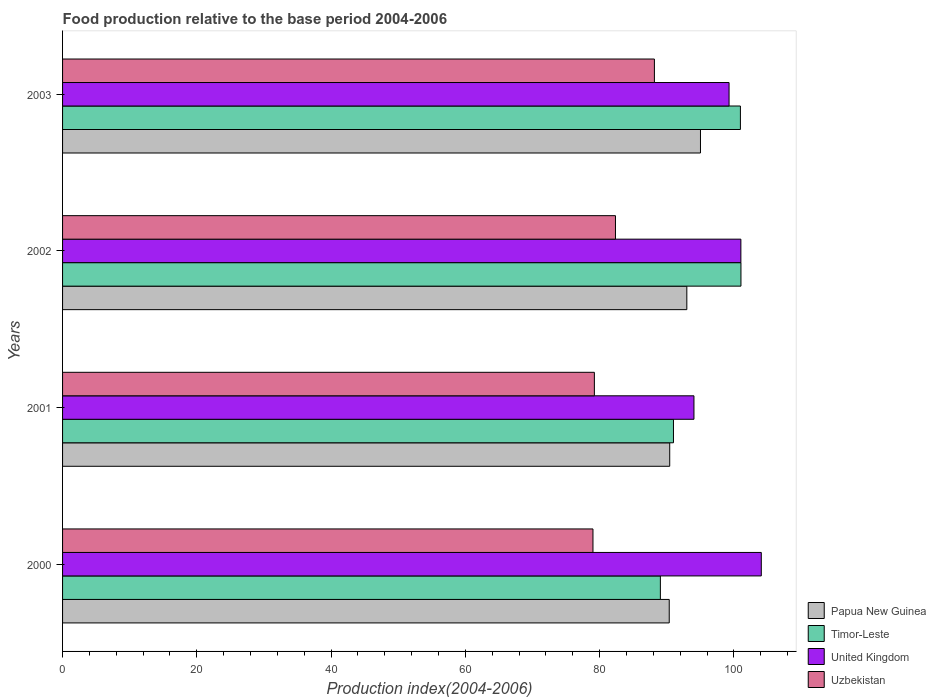How many groups of bars are there?
Offer a terse response. 4. Are the number of bars per tick equal to the number of legend labels?
Make the answer very short. Yes. Are the number of bars on each tick of the Y-axis equal?
Offer a terse response. Yes. How many bars are there on the 2nd tick from the bottom?
Keep it short and to the point. 4. What is the label of the 4th group of bars from the top?
Make the answer very short. 2000. What is the food production index in Timor-Leste in 2000?
Offer a terse response. 89.04. Across all years, what is the maximum food production index in Timor-Leste?
Offer a terse response. 101.04. Across all years, what is the minimum food production index in Timor-Leste?
Your response must be concise. 89.04. In which year was the food production index in Timor-Leste maximum?
Keep it short and to the point. 2002. What is the total food production index in Papua New Guinea in the graph?
Give a very brief answer. 368.78. What is the difference between the food production index in Uzbekistan in 2001 and that in 2003?
Offer a very short reply. -8.94. What is the difference between the food production index in United Kingdom in 2000 and the food production index in Papua New Guinea in 2001?
Your answer should be very brief. 13.64. What is the average food production index in Uzbekistan per year?
Offer a terse response. 82.18. In the year 2001, what is the difference between the food production index in Papua New Guinea and food production index in United Kingdom?
Your answer should be compact. -3.61. What is the ratio of the food production index in Timor-Leste in 2001 to that in 2003?
Give a very brief answer. 0.9. Is the food production index in Uzbekistan in 2002 less than that in 2003?
Give a very brief answer. Yes. What is the difference between the highest and the second highest food production index in United Kingdom?
Offer a very short reply. 3.04. What is the difference between the highest and the lowest food production index in Uzbekistan?
Keep it short and to the point. 9.15. Is the sum of the food production index in United Kingdom in 2000 and 2002 greater than the maximum food production index in Timor-Leste across all years?
Provide a succinct answer. Yes. What does the 1st bar from the top in 2001 represents?
Your answer should be very brief. Uzbekistan. Is it the case that in every year, the sum of the food production index in Timor-Leste and food production index in United Kingdom is greater than the food production index in Uzbekistan?
Your answer should be compact. Yes. How many bars are there?
Your response must be concise. 16. How many years are there in the graph?
Your response must be concise. 4. Does the graph contain any zero values?
Your response must be concise. No. Does the graph contain grids?
Your answer should be compact. No. How are the legend labels stacked?
Keep it short and to the point. Vertical. What is the title of the graph?
Your answer should be compact. Food production relative to the base period 2004-2006. Does "Oman" appear as one of the legend labels in the graph?
Make the answer very short. No. What is the label or title of the X-axis?
Your answer should be compact. Production index(2004-2006). What is the Production index(2004-2006) in Papua New Guinea in 2000?
Offer a very short reply. 90.36. What is the Production index(2004-2006) of Timor-Leste in 2000?
Provide a succinct answer. 89.04. What is the Production index(2004-2006) of United Kingdom in 2000?
Offer a very short reply. 104.07. What is the Production index(2004-2006) in Uzbekistan in 2000?
Your answer should be compact. 79. What is the Production index(2004-2006) of Papua New Guinea in 2001?
Ensure brevity in your answer.  90.43. What is the Production index(2004-2006) in Timor-Leste in 2001?
Your answer should be very brief. 90.99. What is the Production index(2004-2006) in United Kingdom in 2001?
Offer a terse response. 94.04. What is the Production index(2004-2006) of Uzbekistan in 2001?
Ensure brevity in your answer.  79.21. What is the Production index(2004-2006) in Papua New Guinea in 2002?
Make the answer very short. 92.98. What is the Production index(2004-2006) of Timor-Leste in 2002?
Your answer should be very brief. 101.04. What is the Production index(2004-2006) of United Kingdom in 2002?
Make the answer very short. 101.03. What is the Production index(2004-2006) in Uzbekistan in 2002?
Ensure brevity in your answer.  82.35. What is the Production index(2004-2006) of Papua New Guinea in 2003?
Offer a very short reply. 95.01. What is the Production index(2004-2006) of Timor-Leste in 2003?
Your answer should be very brief. 100.96. What is the Production index(2004-2006) of United Kingdom in 2003?
Offer a very short reply. 99.27. What is the Production index(2004-2006) in Uzbekistan in 2003?
Ensure brevity in your answer.  88.15. Across all years, what is the maximum Production index(2004-2006) in Papua New Guinea?
Give a very brief answer. 95.01. Across all years, what is the maximum Production index(2004-2006) of Timor-Leste?
Your answer should be very brief. 101.04. Across all years, what is the maximum Production index(2004-2006) in United Kingdom?
Provide a short and direct response. 104.07. Across all years, what is the maximum Production index(2004-2006) in Uzbekistan?
Make the answer very short. 88.15. Across all years, what is the minimum Production index(2004-2006) in Papua New Guinea?
Offer a terse response. 90.36. Across all years, what is the minimum Production index(2004-2006) in Timor-Leste?
Provide a succinct answer. 89.04. Across all years, what is the minimum Production index(2004-2006) in United Kingdom?
Provide a short and direct response. 94.04. Across all years, what is the minimum Production index(2004-2006) in Uzbekistan?
Offer a very short reply. 79. What is the total Production index(2004-2006) of Papua New Guinea in the graph?
Offer a terse response. 368.78. What is the total Production index(2004-2006) in Timor-Leste in the graph?
Make the answer very short. 382.03. What is the total Production index(2004-2006) in United Kingdom in the graph?
Provide a short and direct response. 398.41. What is the total Production index(2004-2006) of Uzbekistan in the graph?
Your answer should be very brief. 328.71. What is the difference between the Production index(2004-2006) in Papua New Guinea in 2000 and that in 2001?
Your answer should be compact. -0.07. What is the difference between the Production index(2004-2006) of Timor-Leste in 2000 and that in 2001?
Your answer should be compact. -1.95. What is the difference between the Production index(2004-2006) of United Kingdom in 2000 and that in 2001?
Give a very brief answer. 10.03. What is the difference between the Production index(2004-2006) in Uzbekistan in 2000 and that in 2001?
Your answer should be compact. -0.21. What is the difference between the Production index(2004-2006) in Papua New Guinea in 2000 and that in 2002?
Ensure brevity in your answer.  -2.62. What is the difference between the Production index(2004-2006) of United Kingdom in 2000 and that in 2002?
Offer a very short reply. 3.04. What is the difference between the Production index(2004-2006) of Uzbekistan in 2000 and that in 2002?
Your answer should be compact. -3.35. What is the difference between the Production index(2004-2006) of Papua New Guinea in 2000 and that in 2003?
Offer a terse response. -4.65. What is the difference between the Production index(2004-2006) in Timor-Leste in 2000 and that in 2003?
Ensure brevity in your answer.  -11.92. What is the difference between the Production index(2004-2006) of Uzbekistan in 2000 and that in 2003?
Your answer should be compact. -9.15. What is the difference between the Production index(2004-2006) in Papua New Guinea in 2001 and that in 2002?
Ensure brevity in your answer.  -2.55. What is the difference between the Production index(2004-2006) in Timor-Leste in 2001 and that in 2002?
Ensure brevity in your answer.  -10.05. What is the difference between the Production index(2004-2006) of United Kingdom in 2001 and that in 2002?
Offer a terse response. -6.99. What is the difference between the Production index(2004-2006) of Uzbekistan in 2001 and that in 2002?
Offer a terse response. -3.14. What is the difference between the Production index(2004-2006) in Papua New Guinea in 2001 and that in 2003?
Your answer should be compact. -4.58. What is the difference between the Production index(2004-2006) in Timor-Leste in 2001 and that in 2003?
Your response must be concise. -9.97. What is the difference between the Production index(2004-2006) in United Kingdom in 2001 and that in 2003?
Offer a very short reply. -5.23. What is the difference between the Production index(2004-2006) in Uzbekistan in 2001 and that in 2003?
Provide a succinct answer. -8.94. What is the difference between the Production index(2004-2006) of Papua New Guinea in 2002 and that in 2003?
Ensure brevity in your answer.  -2.03. What is the difference between the Production index(2004-2006) of Timor-Leste in 2002 and that in 2003?
Keep it short and to the point. 0.08. What is the difference between the Production index(2004-2006) of United Kingdom in 2002 and that in 2003?
Provide a succinct answer. 1.76. What is the difference between the Production index(2004-2006) of Uzbekistan in 2002 and that in 2003?
Offer a terse response. -5.8. What is the difference between the Production index(2004-2006) in Papua New Guinea in 2000 and the Production index(2004-2006) in Timor-Leste in 2001?
Your response must be concise. -0.63. What is the difference between the Production index(2004-2006) of Papua New Guinea in 2000 and the Production index(2004-2006) of United Kingdom in 2001?
Offer a very short reply. -3.68. What is the difference between the Production index(2004-2006) in Papua New Guinea in 2000 and the Production index(2004-2006) in Uzbekistan in 2001?
Offer a terse response. 11.15. What is the difference between the Production index(2004-2006) in Timor-Leste in 2000 and the Production index(2004-2006) in Uzbekistan in 2001?
Your response must be concise. 9.83. What is the difference between the Production index(2004-2006) of United Kingdom in 2000 and the Production index(2004-2006) of Uzbekistan in 2001?
Offer a very short reply. 24.86. What is the difference between the Production index(2004-2006) of Papua New Guinea in 2000 and the Production index(2004-2006) of Timor-Leste in 2002?
Offer a very short reply. -10.68. What is the difference between the Production index(2004-2006) in Papua New Guinea in 2000 and the Production index(2004-2006) in United Kingdom in 2002?
Offer a very short reply. -10.67. What is the difference between the Production index(2004-2006) in Papua New Guinea in 2000 and the Production index(2004-2006) in Uzbekistan in 2002?
Your answer should be compact. 8.01. What is the difference between the Production index(2004-2006) of Timor-Leste in 2000 and the Production index(2004-2006) of United Kingdom in 2002?
Ensure brevity in your answer.  -11.99. What is the difference between the Production index(2004-2006) of Timor-Leste in 2000 and the Production index(2004-2006) of Uzbekistan in 2002?
Keep it short and to the point. 6.69. What is the difference between the Production index(2004-2006) of United Kingdom in 2000 and the Production index(2004-2006) of Uzbekistan in 2002?
Your answer should be very brief. 21.72. What is the difference between the Production index(2004-2006) of Papua New Guinea in 2000 and the Production index(2004-2006) of Timor-Leste in 2003?
Provide a short and direct response. -10.6. What is the difference between the Production index(2004-2006) in Papua New Guinea in 2000 and the Production index(2004-2006) in United Kingdom in 2003?
Your response must be concise. -8.91. What is the difference between the Production index(2004-2006) of Papua New Guinea in 2000 and the Production index(2004-2006) of Uzbekistan in 2003?
Ensure brevity in your answer.  2.21. What is the difference between the Production index(2004-2006) in Timor-Leste in 2000 and the Production index(2004-2006) in United Kingdom in 2003?
Make the answer very short. -10.23. What is the difference between the Production index(2004-2006) in Timor-Leste in 2000 and the Production index(2004-2006) in Uzbekistan in 2003?
Your answer should be compact. 0.89. What is the difference between the Production index(2004-2006) in United Kingdom in 2000 and the Production index(2004-2006) in Uzbekistan in 2003?
Keep it short and to the point. 15.92. What is the difference between the Production index(2004-2006) of Papua New Guinea in 2001 and the Production index(2004-2006) of Timor-Leste in 2002?
Make the answer very short. -10.61. What is the difference between the Production index(2004-2006) of Papua New Guinea in 2001 and the Production index(2004-2006) of Uzbekistan in 2002?
Keep it short and to the point. 8.08. What is the difference between the Production index(2004-2006) in Timor-Leste in 2001 and the Production index(2004-2006) in United Kingdom in 2002?
Offer a terse response. -10.04. What is the difference between the Production index(2004-2006) in Timor-Leste in 2001 and the Production index(2004-2006) in Uzbekistan in 2002?
Give a very brief answer. 8.64. What is the difference between the Production index(2004-2006) of United Kingdom in 2001 and the Production index(2004-2006) of Uzbekistan in 2002?
Make the answer very short. 11.69. What is the difference between the Production index(2004-2006) in Papua New Guinea in 2001 and the Production index(2004-2006) in Timor-Leste in 2003?
Provide a succinct answer. -10.53. What is the difference between the Production index(2004-2006) of Papua New Guinea in 2001 and the Production index(2004-2006) of United Kingdom in 2003?
Offer a terse response. -8.84. What is the difference between the Production index(2004-2006) in Papua New Guinea in 2001 and the Production index(2004-2006) in Uzbekistan in 2003?
Your answer should be very brief. 2.28. What is the difference between the Production index(2004-2006) of Timor-Leste in 2001 and the Production index(2004-2006) of United Kingdom in 2003?
Ensure brevity in your answer.  -8.28. What is the difference between the Production index(2004-2006) of Timor-Leste in 2001 and the Production index(2004-2006) of Uzbekistan in 2003?
Your answer should be compact. 2.84. What is the difference between the Production index(2004-2006) of United Kingdom in 2001 and the Production index(2004-2006) of Uzbekistan in 2003?
Provide a succinct answer. 5.89. What is the difference between the Production index(2004-2006) in Papua New Guinea in 2002 and the Production index(2004-2006) in Timor-Leste in 2003?
Your response must be concise. -7.98. What is the difference between the Production index(2004-2006) of Papua New Guinea in 2002 and the Production index(2004-2006) of United Kingdom in 2003?
Your answer should be very brief. -6.29. What is the difference between the Production index(2004-2006) in Papua New Guinea in 2002 and the Production index(2004-2006) in Uzbekistan in 2003?
Offer a very short reply. 4.83. What is the difference between the Production index(2004-2006) in Timor-Leste in 2002 and the Production index(2004-2006) in United Kingdom in 2003?
Your answer should be compact. 1.77. What is the difference between the Production index(2004-2006) in Timor-Leste in 2002 and the Production index(2004-2006) in Uzbekistan in 2003?
Provide a short and direct response. 12.89. What is the difference between the Production index(2004-2006) in United Kingdom in 2002 and the Production index(2004-2006) in Uzbekistan in 2003?
Your answer should be compact. 12.88. What is the average Production index(2004-2006) of Papua New Guinea per year?
Your answer should be very brief. 92.19. What is the average Production index(2004-2006) of Timor-Leste per year?
Offer a terse response. 95.51. What is the average Production index(2004-2006) of United Kingdom per year?
Provide a succinct answer. 99.6. What is the average Production index(2004-2006) of Uzbekistan per year?
Give a very brief answer. 82.18. In the year 2000, what is the difference between the Production index(2004-2006) in Papua New Guinea and Production index(2004-2006) in Timor-Leste?
Offer a terse response. 1.32. In the year 2000, what is the difference between the Production index(2004-2006) of Papua New Guinea and Production index(2004-2006) of United Kingdom?
Ensure brevity in your answer.  -13.71. In the year 2000, what is the difference between the Production index(2004-2006) in Papua New Guinea and Production index(2004-2006) in Uzbekistan?
Offer a terse response. 11.36. In the year 2000, what is the difference between the Production index(2004-2006) in Timor-Leste and Production index(2004-2006) in United Kingdom?
Ensure brevity in your answer.  -15.03. In the year 2000, what is the difference between the Production index(2004-2006) of Timor-Leste and Production index(2004-2006) of Uzbekistan?
Your answer should be very brief. 10.04. In the year 2000, what is the difference between the Production index(2004-2006) of United Kingdom and Production index(2004-2006) of Uzbekistan?
Offer a very short reply. 25.07. In the year 2001, what is the difference between the Production index(2004-2006) of Papua New Guinea and Production index(2004-2006) of Timor-Leste?
Your response must be concise. -0.56. In the year 2001, what is the difference between the Production index(2004-2006) of Papua New Guinea and Production index(2004-2006) of United Kingdom?
Keep it short and to the point. -3.61. In the year 2001, what is the difference between the Production index(2004-2006) in Papua New Guinea and Production index(2004-2006) in Uzbekistan?
Offer a very short reply. 11.22. In the year 2001, what is the difference between the Production index(2004-2006) in Timor-Leste and Production index(2004-2006) in United Kingdom?
Give a very brief answer. -3.05. In the year 2001, what is the difference between the Production index(2004-2006) in Timor-Leste and Production index(2004-2006) in Uzbekistan?
Make the answer very short. 11.78. In the year 2001, what is the difference between the Production index(2004-2006) of United Kingdom and Production index(2004-2006) of Uzbekistan?
Ensure brevity in your answer.  14.83. In the year 2002, what is the difference between the Production index(2004-2006) of Papua New Guinea and Production index(2004-2006) of Timor-Leste?
Your answer should be very brief. -8.06. In the year 2002, what is the difference between the Production index(2004-2006) in Papua New Guinea and Production index(2004-2006) in United Kingdom?
Provide a short and direct response. -8.05. In the year 2002, what is the difference between the Production index(2004-2006) of Papua New Guinea and Production index(2004-2006) of Uzbekistan?
Offer a terse response. 10.63. In the year 2002, what is the difference between the Production index(2004-2006) of Timor-Leste and Production index(2004-2006) of Uzbekistan?
Your response must be concise. 18.69. In the year 2002, what is the difference between the Production index(2004-2006) in United Kingdom and Production index(2004-2006) in Uzbekistan?
Your answer should be very brief. 18.68. In the year 2003, what is the difference between the Production index(2004-2006) of Papua New Guinea and Production index(2004-2006) of Timor-Leste?
Offer a very short reply. -5.95. In the year 2003, what is the difference between the Production index(2004-2006) in Papua New Guinea and Production index(2004-2006) in United Kingdom?
Provide a succinct answer. -4.26. In the year 2003, what is the difference between the Production index(2004-2006) in Papua New Guinea and Production index(2004-2006) in Uzbekistan?
Ensure brevity in your answer.  6.86. In the year 2003, what is the difference between the Production index(2004-2006) of Timor-Leste and Production index(2004-2006) of United Kingdom?
Provide a succinct answer. 1.69. In the year 2003, what is the difference between the Production index(2004-2006) of Timor-Leste and Production index(2004-2006) of Uzbekistan?
Provide a short and direct response. 12.81. In the year 2003, what is the difference between the Production index(2004-2006) in United Kingdom and Production index(2004-2006) in Uzbekistan?
Your answer should be compact. 11.12. What is the ratio of the Production index(2004-2006) of Papua New Guinea in 2000 to that in 2001?
Provide a short and direct response. 1. What is the ratio of the Production index(2004-2006) of Timor-Leste in 2000 to that in 2001?
Your response must be concise. 0.98. What is the ratio of the Production index(2004-2006) of United Kingdom in 2000 to that in 2001?
Make the answer very short. 1.11. What is the ratio of the Production index(2004-2006) in Uzbekistan in 2000 to that in 2001?
Your answer should be very brief. 1. What is the ratio of the Production index(2004-2006) of Papua New Guinea in 2000 to that in 2002?
Your answer should be compact. 0.97. What is the ratio of the Production index(2004-2006) of Timor-Leste in 2000 to that in 2002?
Provide a short and direct response. 0.88. What is the ratio of the Production index(2004-2006) in United Kingdom in 2000 to that in 2002?
Offer a very short reply. 1.03. What is the ratio of the Production index(2004-2006) in Uzbekistan in 2000 to that in 2002?
Give a very brief answer. 0.96. What is the ratio of the Production index(2004-2006) of Papua New Guinea in 2000 to that in 2003?
Your response must be concise. 0.95. What is the ratio of the Production index(2004-2006) in Timor-Leste in 2000 to that in 2003?
Offer a very short reply. 0.88. What is the ratio of the Production index(2004-2006) in United Kingdom in 2000 to that in 2003?
Your response must be concise. 1.05. What is the ratio of the Production index(2004-2006) of Uzbekistan in 2000 to that in 2003?
Keep it short and to the point. 0.9. What is the ratio of the Production index(2004-2006) of Papua New Guinea in 2001 to that in 2002?
Your answer should be compact. 0.97. What is the ratio of the Production index(2004-2006) in Timor-Leste in 2001 to that in 2002?
Your answer should be very brief. 0.9. What is the ratio of the Production index(2004-2006) in United Kingdom in 2001 to that in 2002?
Make the answer very short. 0.93. What is the ratio of the Production index(2004-2006) of Uzbekistan in 2001 to that in 2002?
Offer a very short reply. 0.96. What is the ratio of the Production index(2004-2006) in Papua New Guinea in 2001 to that in 2003?
Offer a terse response. 0.95. What is the ratio of the Production index(2004-2006) in Timor-Leste in 2001 to that in 2003?
Make the answer very short. 0.9. What is the ratio of the Production index(2004-2006) in United Kingdom in 2001 to that in 2003?
Keep it short and to the point. 0.95. What is the ratio of the Production index(2004-2006) of Uzbekistan in 2001 to that in 2003?
Keep it short and to the point. 0.9. What is the ratio of the Production index(2004-2006) of Papua New Guinea in 2002 to that in 2003?
Make the answer very short. 0.98. What is the ratio of the Production index(2004-2006) in United Kingdom in 2002 to that in 2003?
Offer a terse response. 1.02. What is the ratio of the Production index(2004-2006) of Uzbekistan in 2002 to that in 2003?
Your answer should be very brief. 0.93. What is the difference between the highest and the second highest Production index(2004-2006) in Papua New Guinea?
Give a very brief answer. 2.03. What is the difference between the highest and the second highest Production index(2004-2006) in Timor-Leste?
Keep it short and to the point. 0.08. What is the difference between the highest and the second highest Production index(2004-2006) of United Kingdom?
Keep it short and to the point. 3.04. What is the difference between the highest and the lowest Production index(2004-2006) of Papua New Guinea?
Make the answer very short. 4.65. What is the difference between the highest and the lowest Production index(2004-2006) in United Kingdom?
Ensure brevity in your answer.  10.03. What is the difference between the highest and the lowest Production index(2004-2006) of Uzbekistan?
Keep it short and to the point. 9.15. 